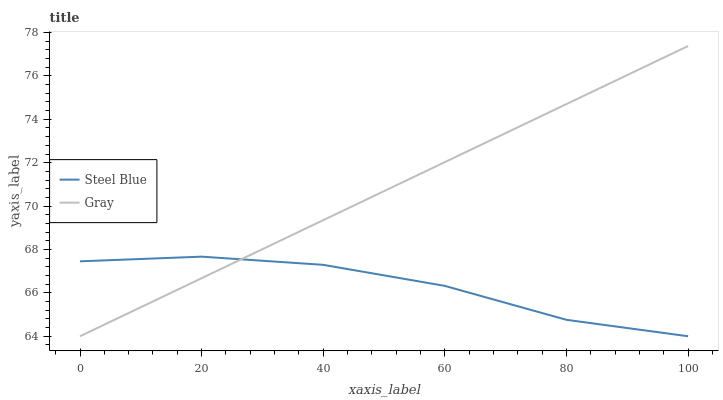Does Steel Blue have the minimum area under the curve?
Answer yes or no. Yes. Does Gray have the maximum area under the curve?
Answer yes or no. Yes. Does Steel Blue have the maximum area under the curve?
Answer yes or no. No. Is Gray the smoothest?
Answer yes or no. Yes. Is Steel Blue the roughest?
Answer yes or no. Yes. Is Steel Blue the smoothest?
Answer yes or no. No. Does Gray have the lowest value?
Answer yes or no. Yes. Does Gray have the highest value?
Answer yes or no. Yes. Does Steel Blue have the highest value?
Answer yes or no. No. Does Steel Blue intersect Gray?
Answer yes or no. Yes. Is Steel Blue less than Gray?
Answer yes or no. No. Is Steel Blue greater than Gray?
Answer yes or no. No. 